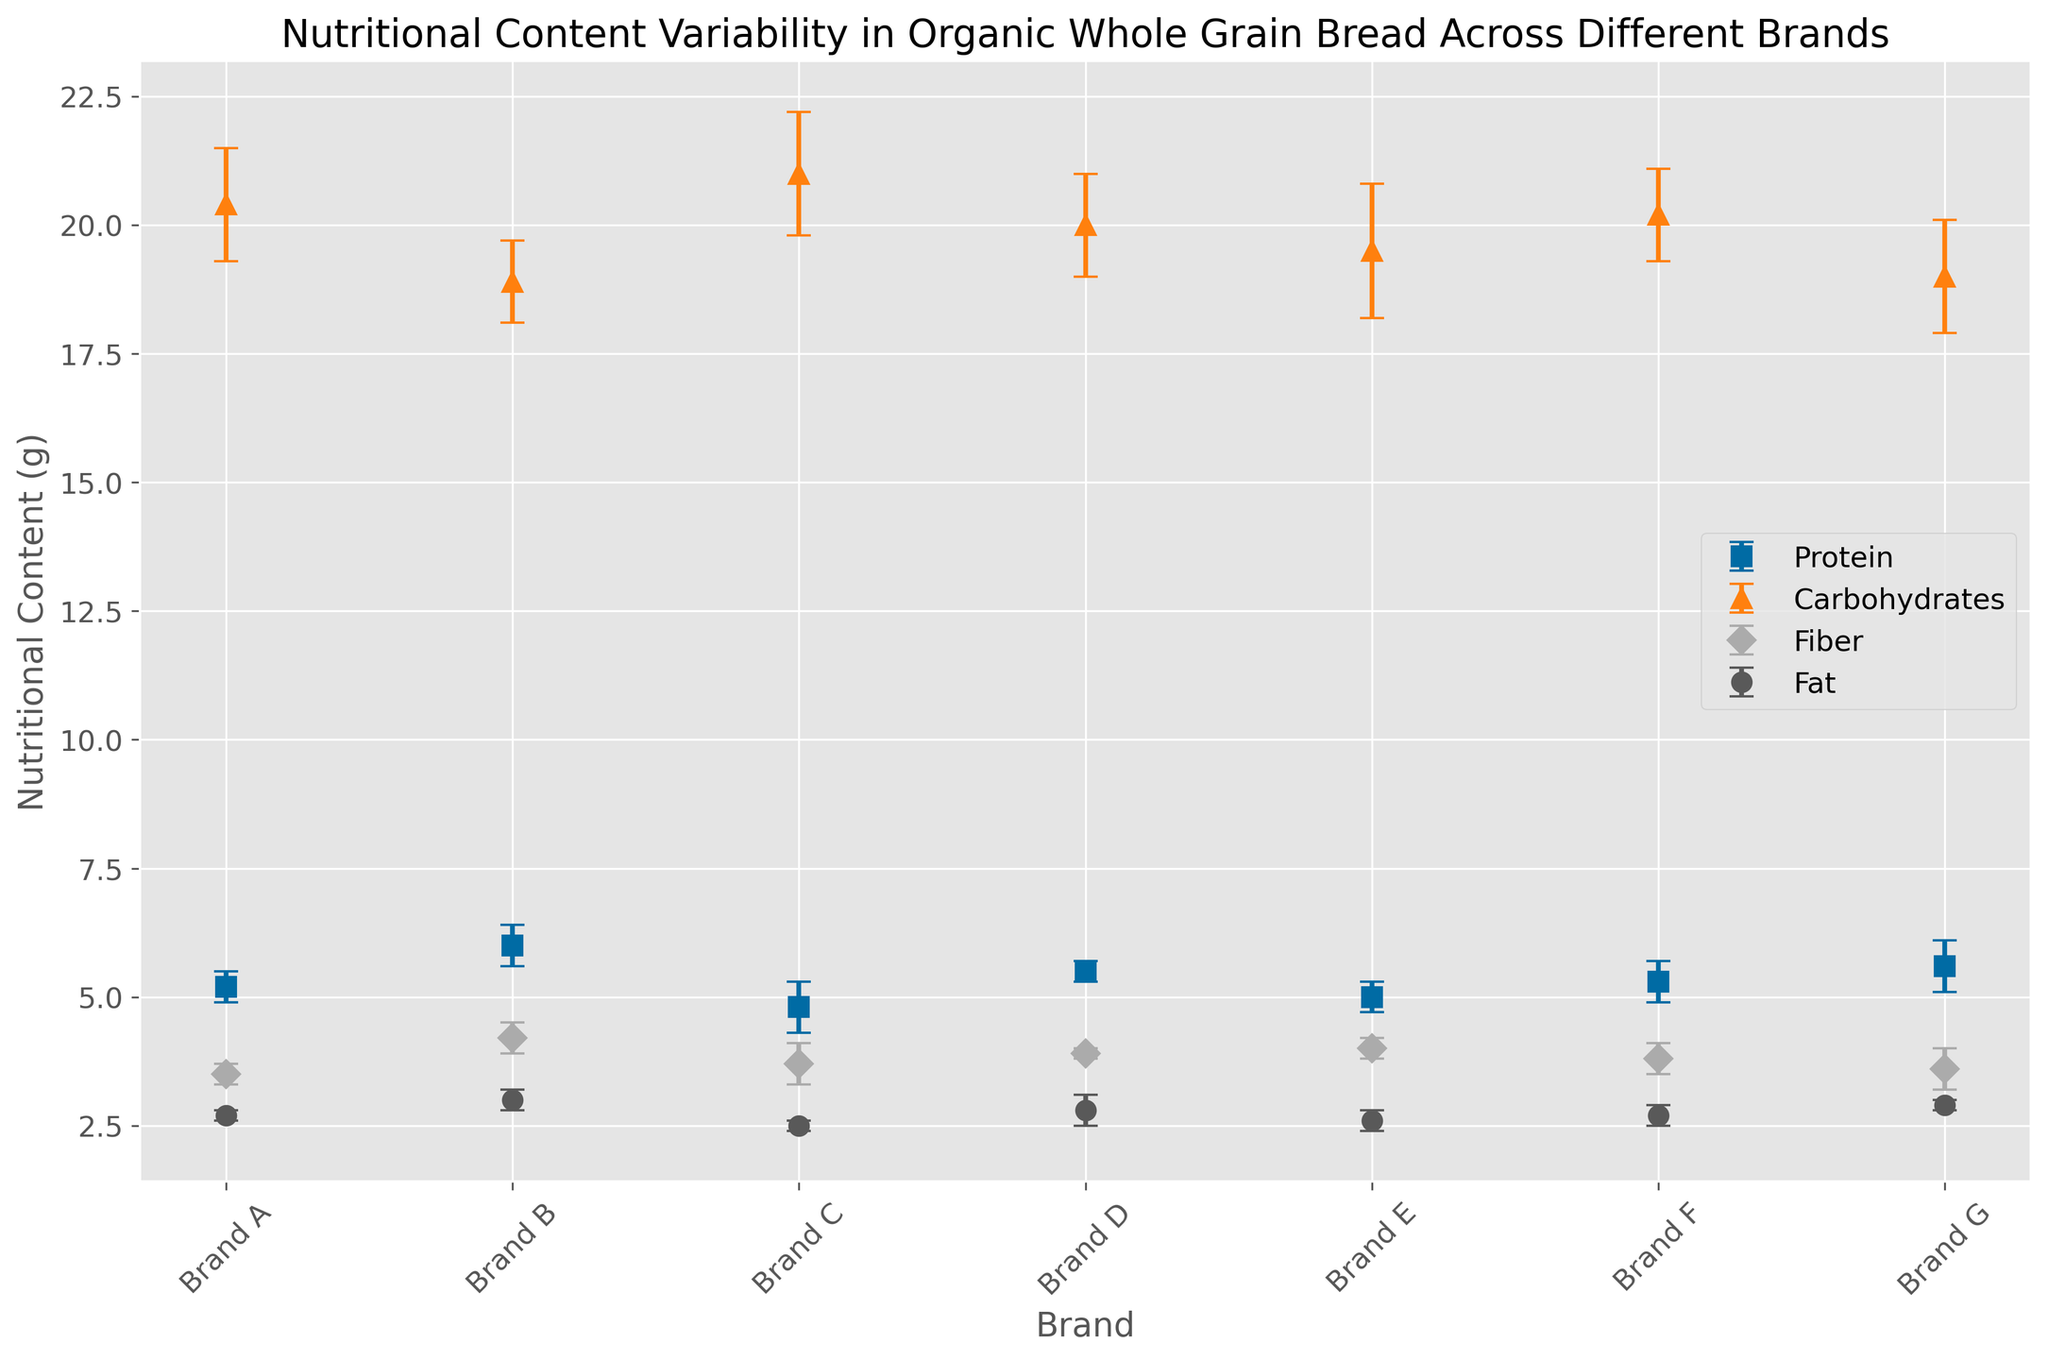Which brand has the highest average protein content? By looking at the error bars corresponding to protein content, identify which point on the plot is the highest. The highest point on the protein line is Brand B with an average protein content of 6.0 grams.
Answer: Brand B Which brand shows the smallest variability in fiber content? Observe the error bars for fiber content. The smallest error bar, indicating the least variability, corresponds to Brand D.
Answer: Brand D What is the difference in average carbohydrate content between Brand A and Brand G? Locate the carbohydrate values for Brand A (20.4 grams) and Brand G (19.0 grams). Subtract the latter from the former: 20.4 - 19.0 = 1.4 grams.
Answer: 1.4 grams Which nutritional component (protein, carbohydrates, fiber, or fat) exhibits the highest variability across all brands? Compare the lengths of all error bars for each nutritional component. The longest overall error bars are for carbohydrates, indicating the highest variability.
Answer: Carbohydrates What is the average fat content across all brands? Sum the mean fat values for all brands: (2.7 + 3.0 + 2.5 + 2.8 + 2.6 + 2.7 + 2.9) = 19.2 grams. Then divide by the number of brands (7): 19.2/7 ≈ 2.74 grams.
Answer: 2.74 grams If you were to rank the brands based on their average fiber content, which brand comes last? Compare the average fiber content across brands. The lowest value is for Brand A at 3.5 grams.
Answer: Brand A How does the average protein content of Brand F compare to that of Brand C? Compare the protein content values for Brand F (5.3 grams) and Brand C (4.8 grams). Brand F has a higher average protein content.
Answer: Brand F Which brand has an average fat content closest to the overall average fat content? The overall average fat content is approximately 2.74 grams. The brands with mean fat contents closest to this value are Brands A (2.7 grams) and F (2.7 grams). Evaluate the deviation:
Answer: Brand A or Brand F What is the sum of the average protein and fiber content for Brand D? The average protein content for Brand D is 5.5 grams, and the fiber content is 3.9 grams. Add these two values together: 5.5 + 3.9 = 9.4 grams.
Answer: 9.4 grams Between Brand B and Brand E, which one has more carbohydrate variability? Compare the length of the error bars for carbohydrates for Brand B (0.8 grams) and Brand E (1.3 grams). Brand E shows more variability.
Answer: Brand E 